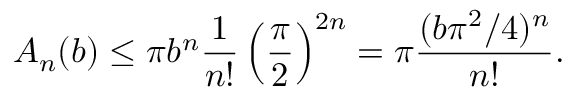<formula> <loc_0><loc_0><loc_500><loc_500>A _ { n } ( b ) \leq \pi b ^ { n } { \frac { 1 } { n ! } } \left ( { \frac { \pi } { 2 } } \right ) ^ { 2 n } = \pi { \frac { ( b \pi ^ { 2 } / 4 ) ^ { n } } { n ! } } .</formula> 